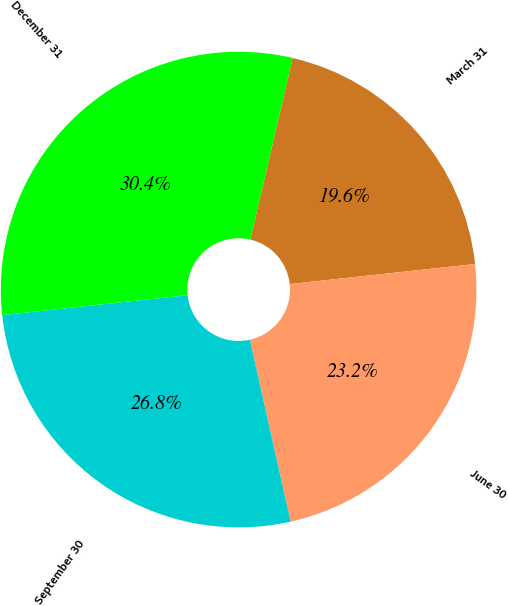Convert chart to OTSL. <chart><loc_0><loc_0><loc_500><loc_500><pie_chart><fcel>March 31<fcel>June 30<fcel>September 30<fcel>December 31<nl><fcel>19.64%<fcel>23.21%<fcel>26.79%<fcel>30.36%<nl></chart> 